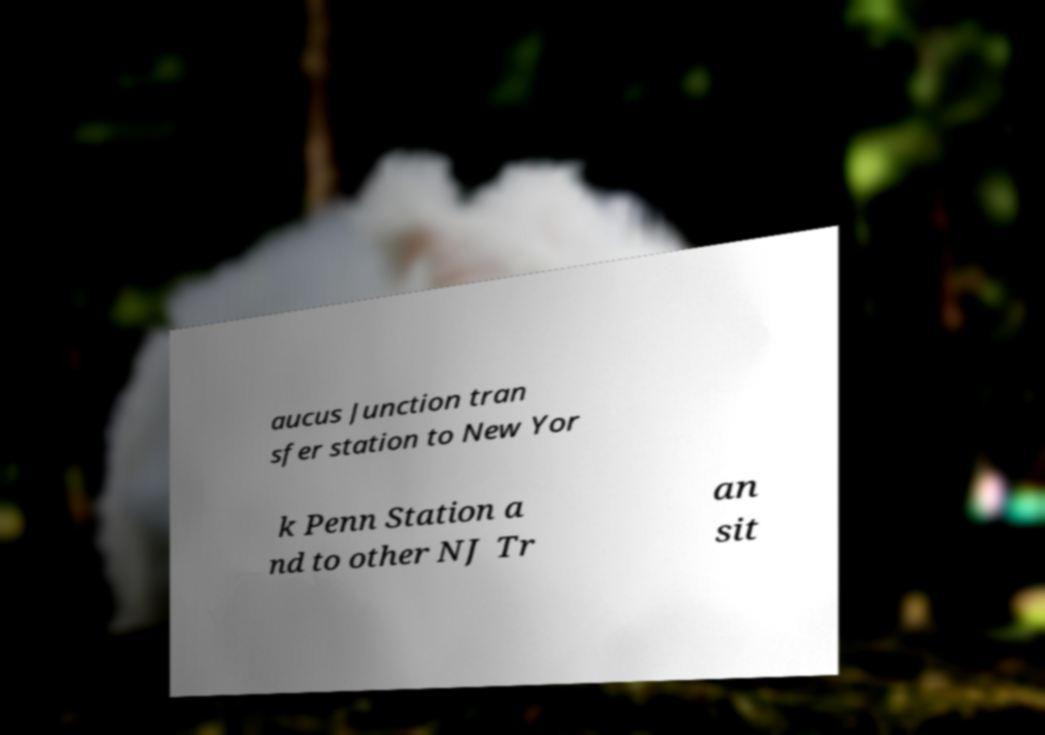I need the written content from this picture converted into text. Can you do that? aucus Junction tran sfer station to New Yor k Penn Station a nd to other NJ Tr an sit 